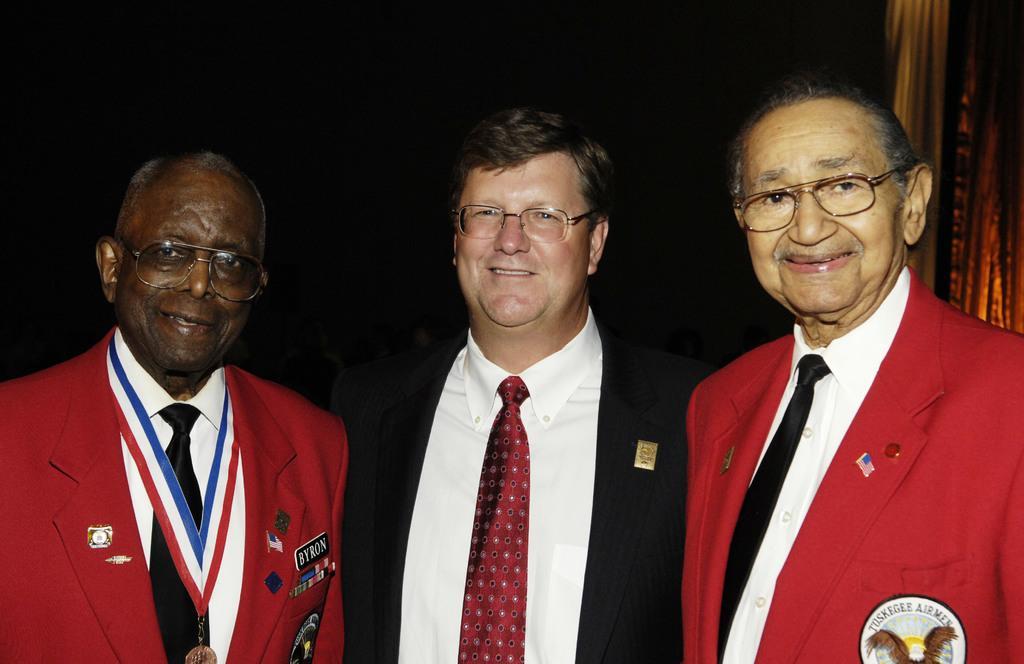Could you give a brief overview of what you see in this image? In this image there are three men who are wearing the suits. The man on the left side is wearing the gold medal. In the background there is a curtain. All the three men are having the spectacles. 